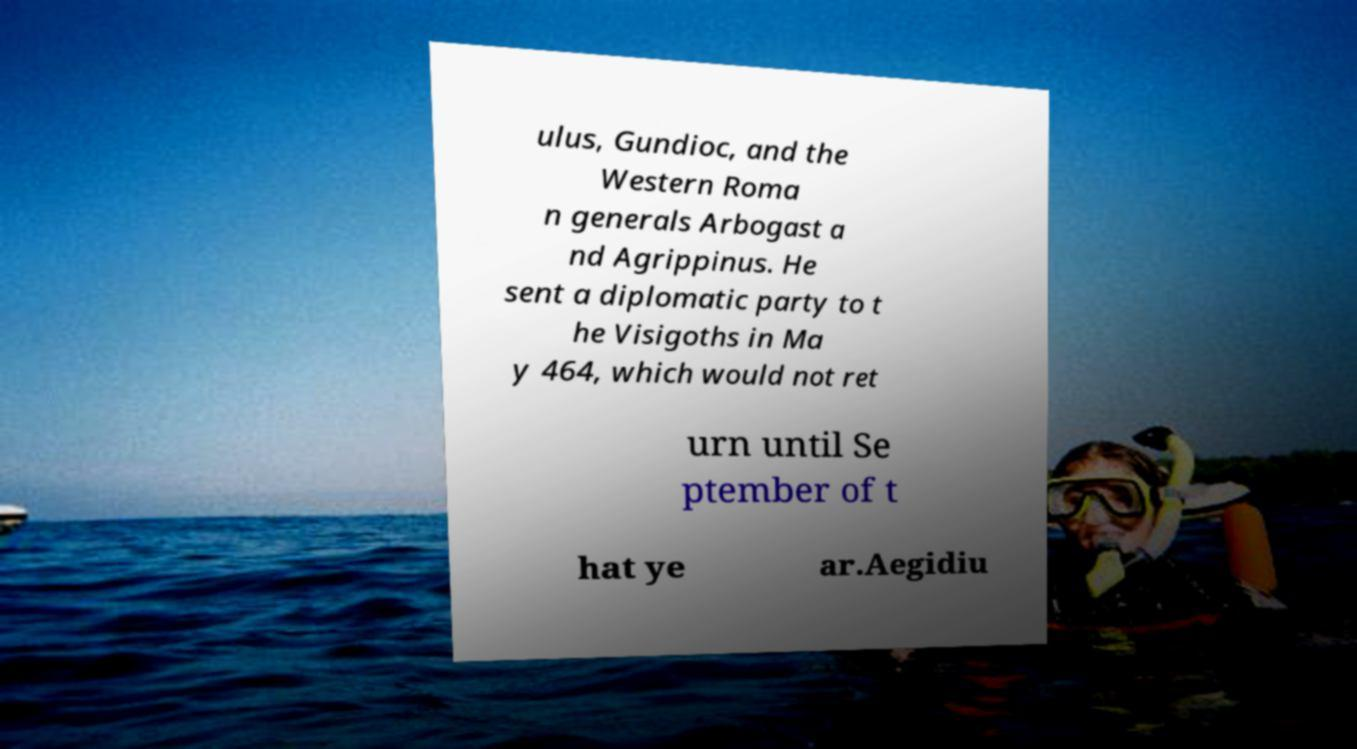Can you accurately transcribe the text from the provided image for me? ulus, Gundioc, and the Western Roma n generals Arbogast a nd Agrippinus. He sent a diplomatic party to t he Visigoths in Ma y 464, which would not ret urn until Se ptember of t hat ye ar.Aegidiu 